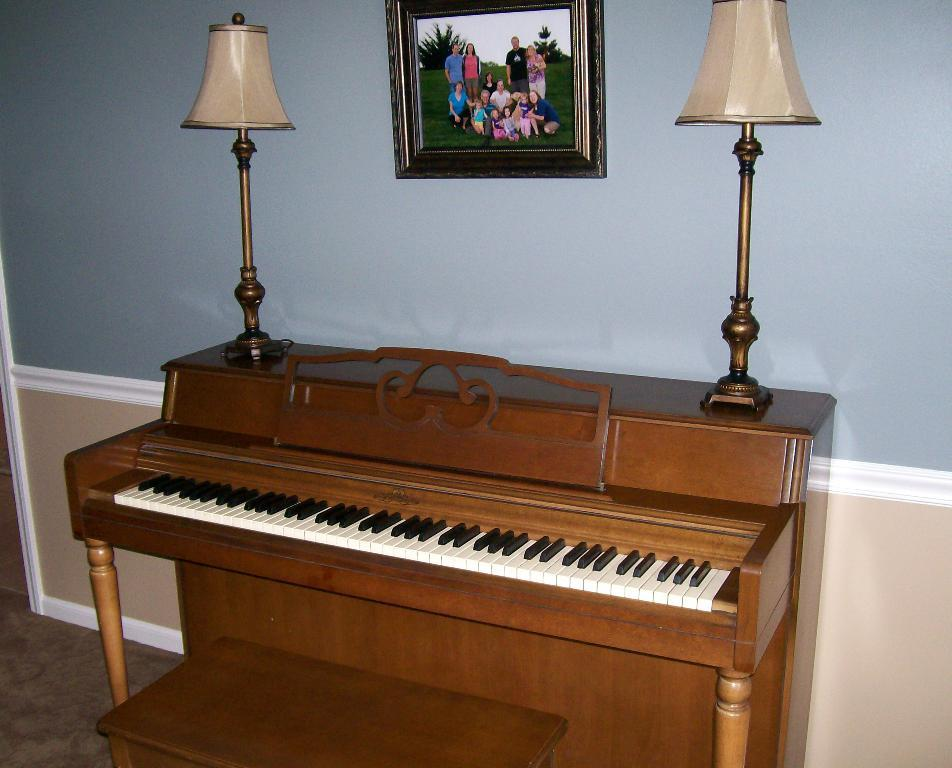What is the main object in the image? There is a piano in the image. Are there any additional objects on the piano? Yes, there are 2 lamps on the piano. Can you describe anything on the wall in the image? There is a photo frame on the wall. What type of rice is being cooked in the image? There is no rice present in the image; it features a piano with lamps and a photo frame on the wall. How many people are whistling in the image? There are no people whistling in the image; it features a piano with lamps and a photo frame on the wall. 